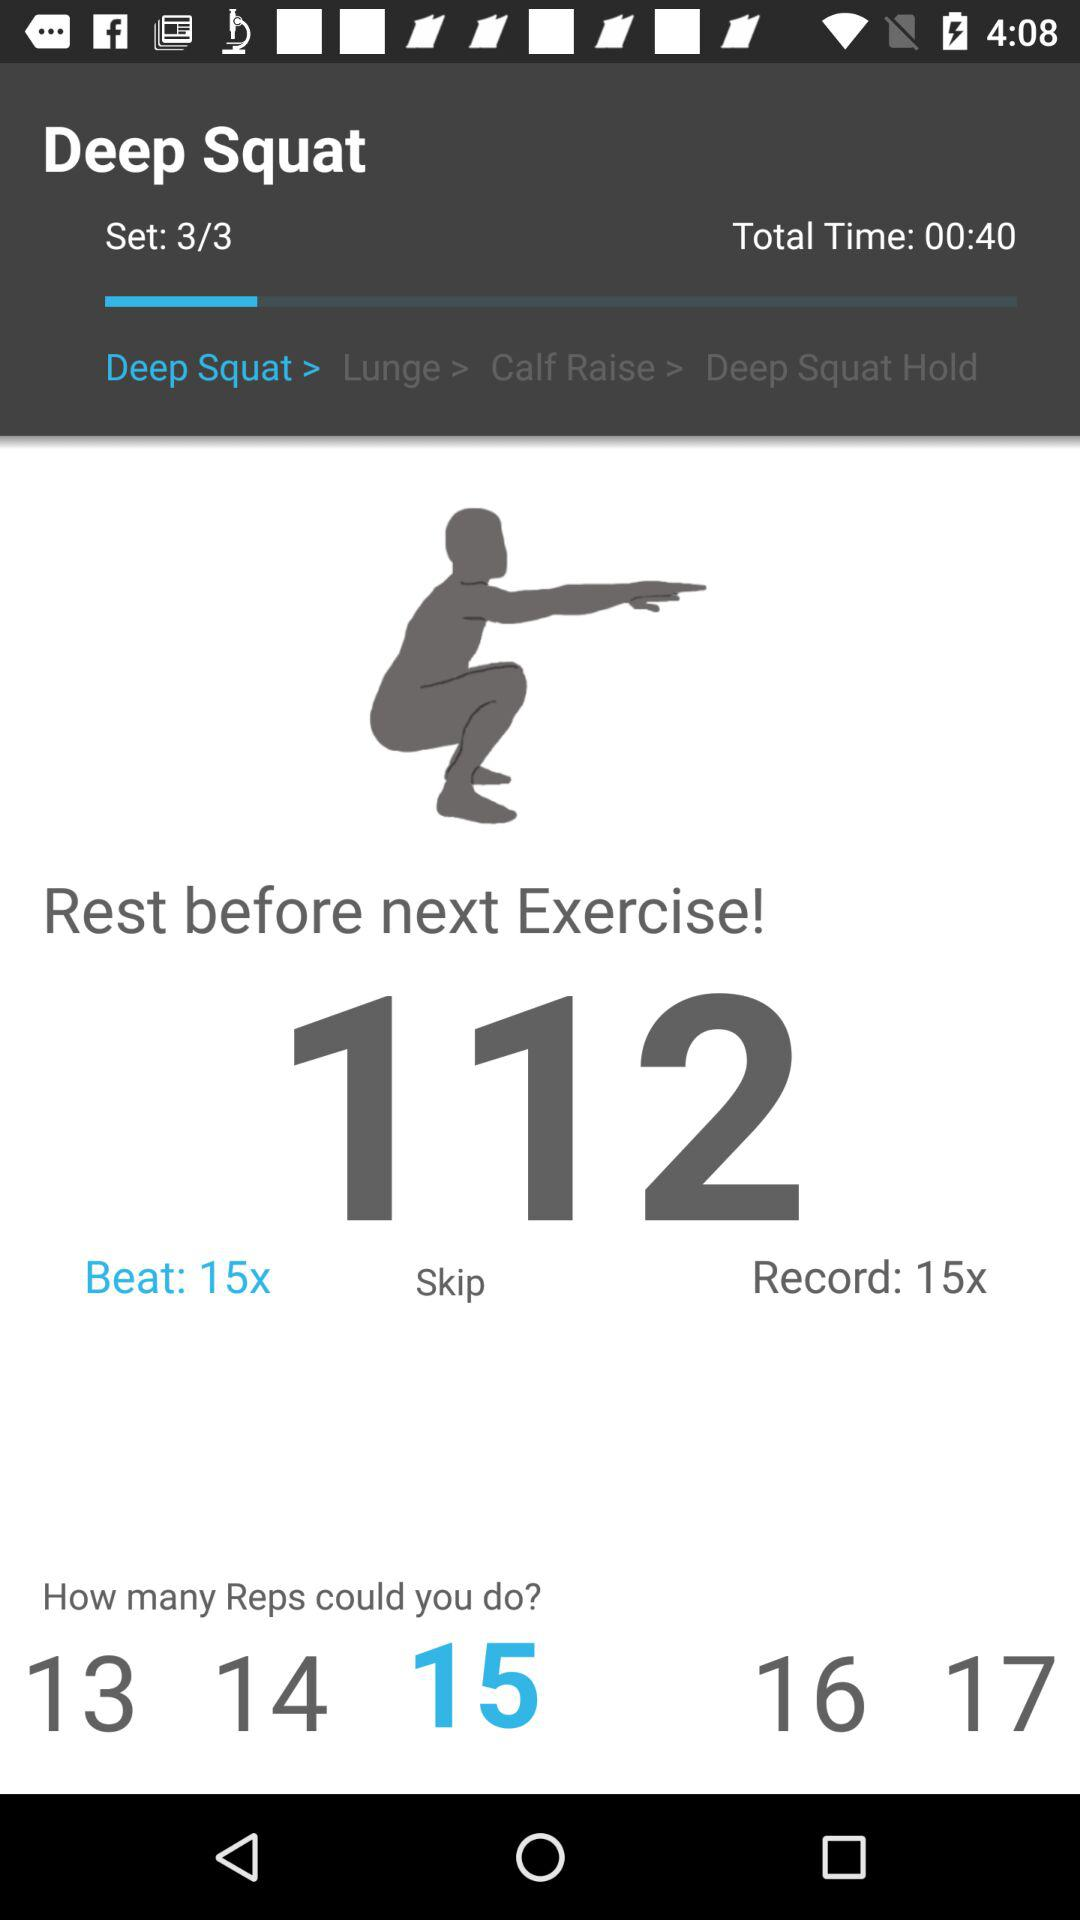How many sets are there for the "Deep Squat"? There are 3 sets. 